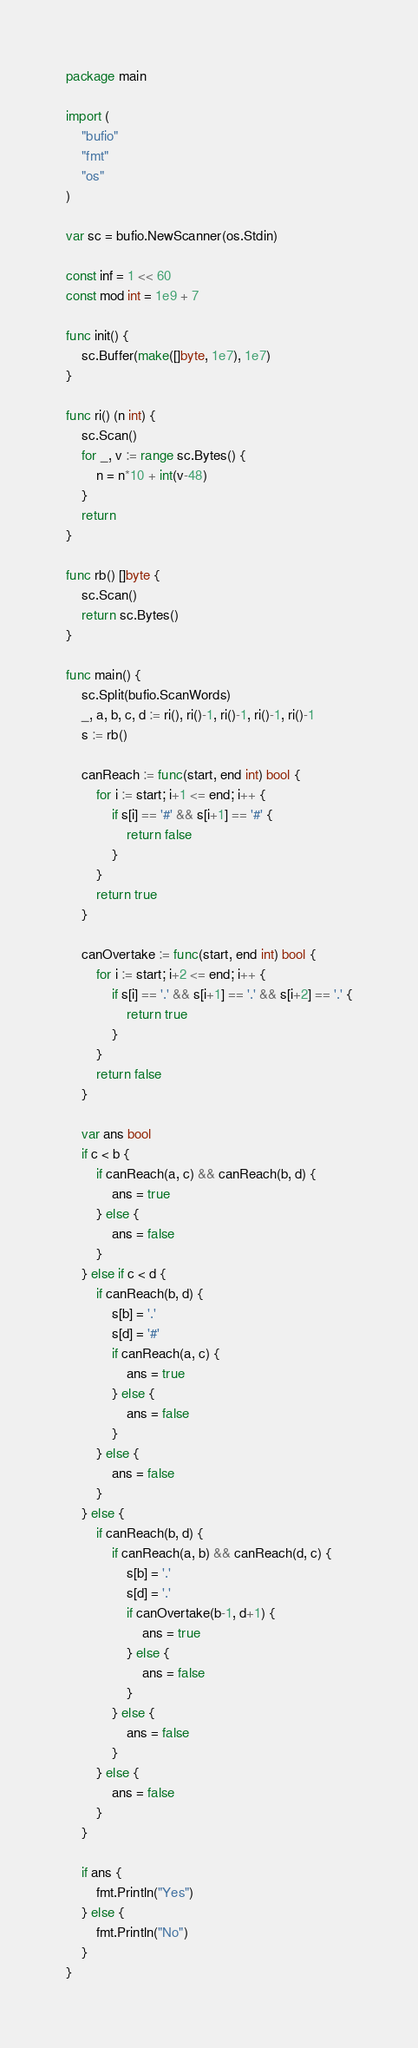Convert code to text. <code><loc_0><loc_0><loc_500><loc_500><_Go_>package main

import (
	"bufio"
	"fmt"
	"os"
)

var sc = bufio.NewScanner(os.Stdin)

const inf = 1 << 60
const mod int = 1e9 + 7

func init() {
	sc.Buffer(make([]byte, 1e7), 1e7)
}

func ri() (n int) {
	sc.Scan()
	for _, v := range sc.Bytes() {
		n = n*10 + int(v-48)
	}
	return
}

func rb() []byte {
	sc.Scan()
	return sc.Bytes()
}

func main() {
	sc.Split(bufio.ScanWords)
	_, a, b, c, d := ri(), ri()-1, ri()-1, ri()-1, ri()-1
	s := rb()

	canReach := func(start, end int) bool {
		for i := start; i+1 <= end; i++ {
			if s[i] == '#' && s[i+1] == '#' {
				return false
			}
		}
		return true
	}

	canOvertake := func(start, end int) bool {
		for i := start; i+2 <= end; i++ {
			if s[i] == '.' && s[i+1] == '.' && s[i+2] == '.' {
				return true
			}
		}
		return false
	}

	var ans bool
	if c < b {
		if canReach(a, c) && canReach(b, d) {
			ans = true
		} else {
			ans = false
		}
	} else if c < d {
		if canReach(b, d) {
			s[b] = '.'
			s[d] = '#'
			if canReach(a, c) {
				ans = true
			} else {
				ans = false
			}
		} else {
			ans = false
		}
	} else {
		if canReach(b, d) {
			if canReach(a, b) && canReach(d, c) {
				s[b] = '.'
				s[d] = '.'
				if canOvertake(b-1, d+1) {
					ans = true
				} else {
					ans = false
				}
			} else {
				ans = false
			}
		} else {
			ans = false
		}
	}

	if ans {
		fmt.Println("Yes")
	} else {
		fmt.Println("No")
	}
}
</code> 